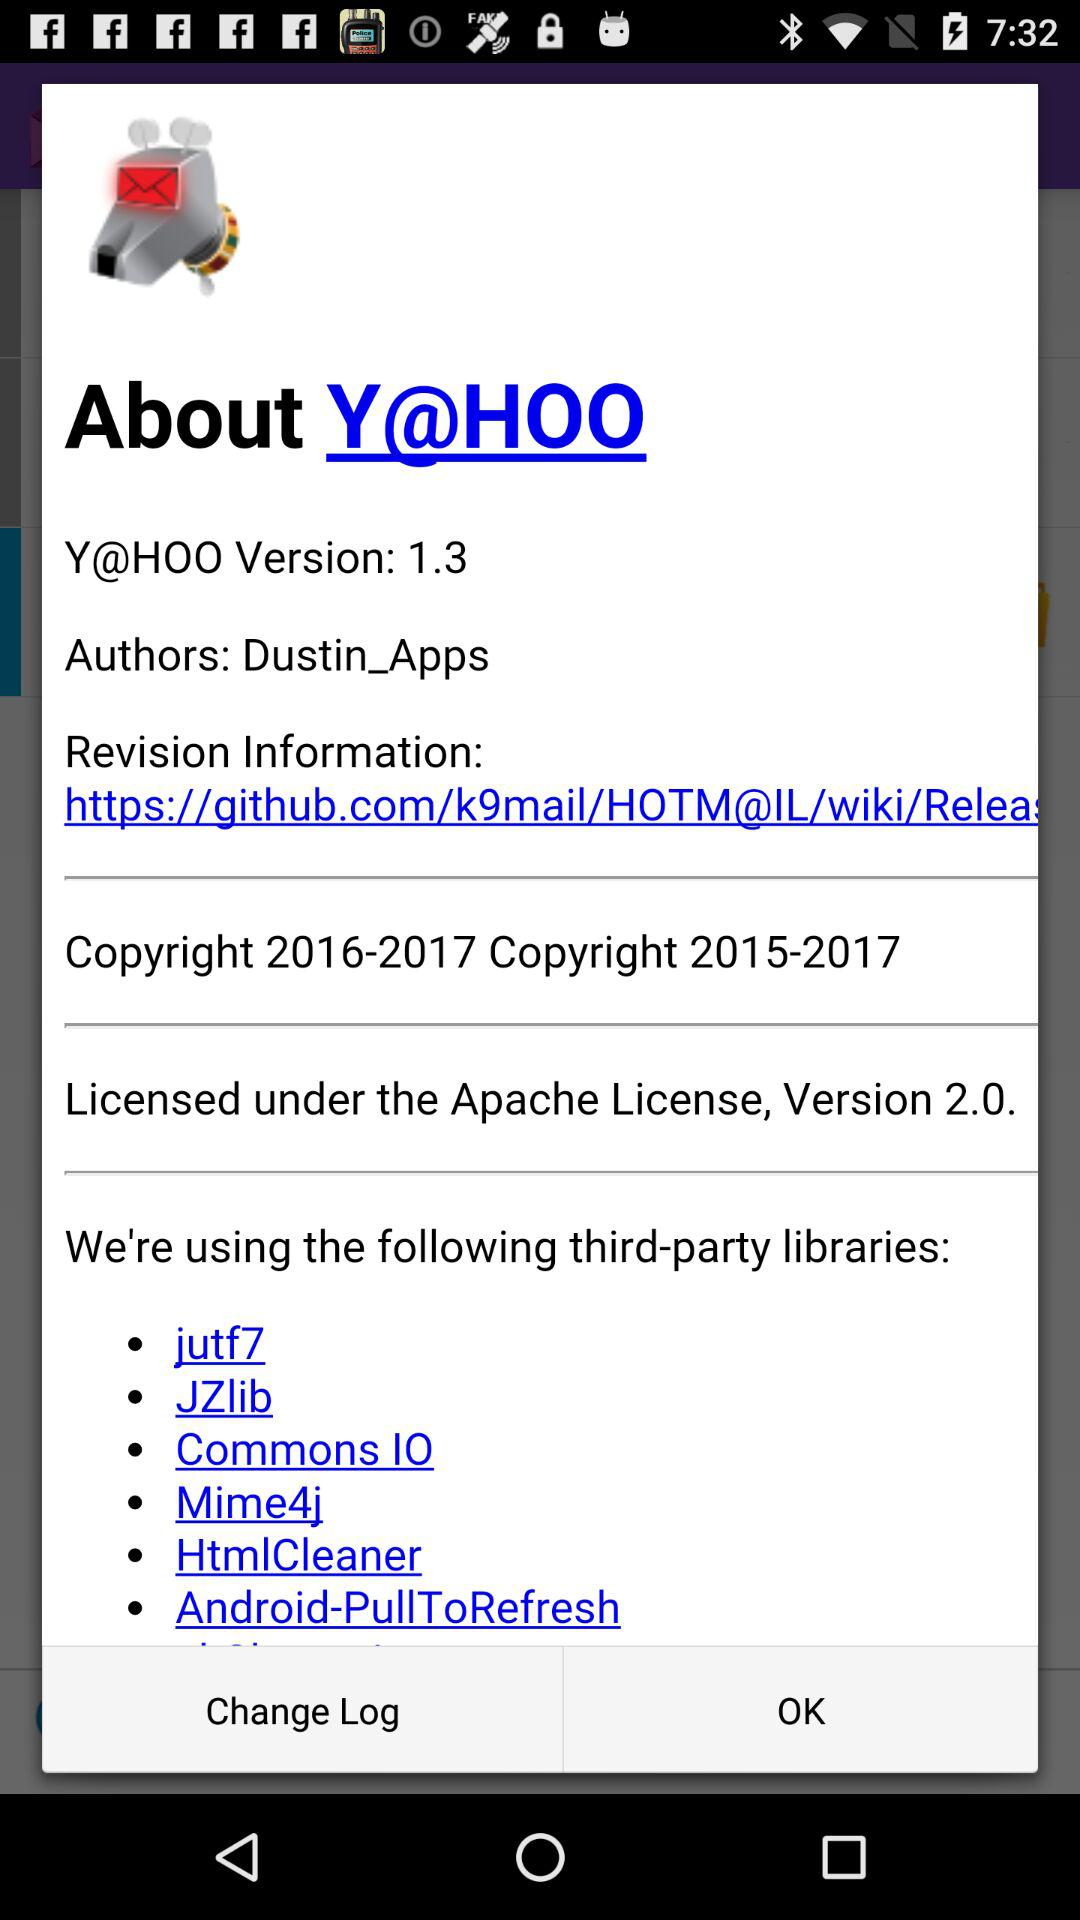Who is the author of "Y@HOO"? The author of "Y@HOO" is "Dustin_Apps". 